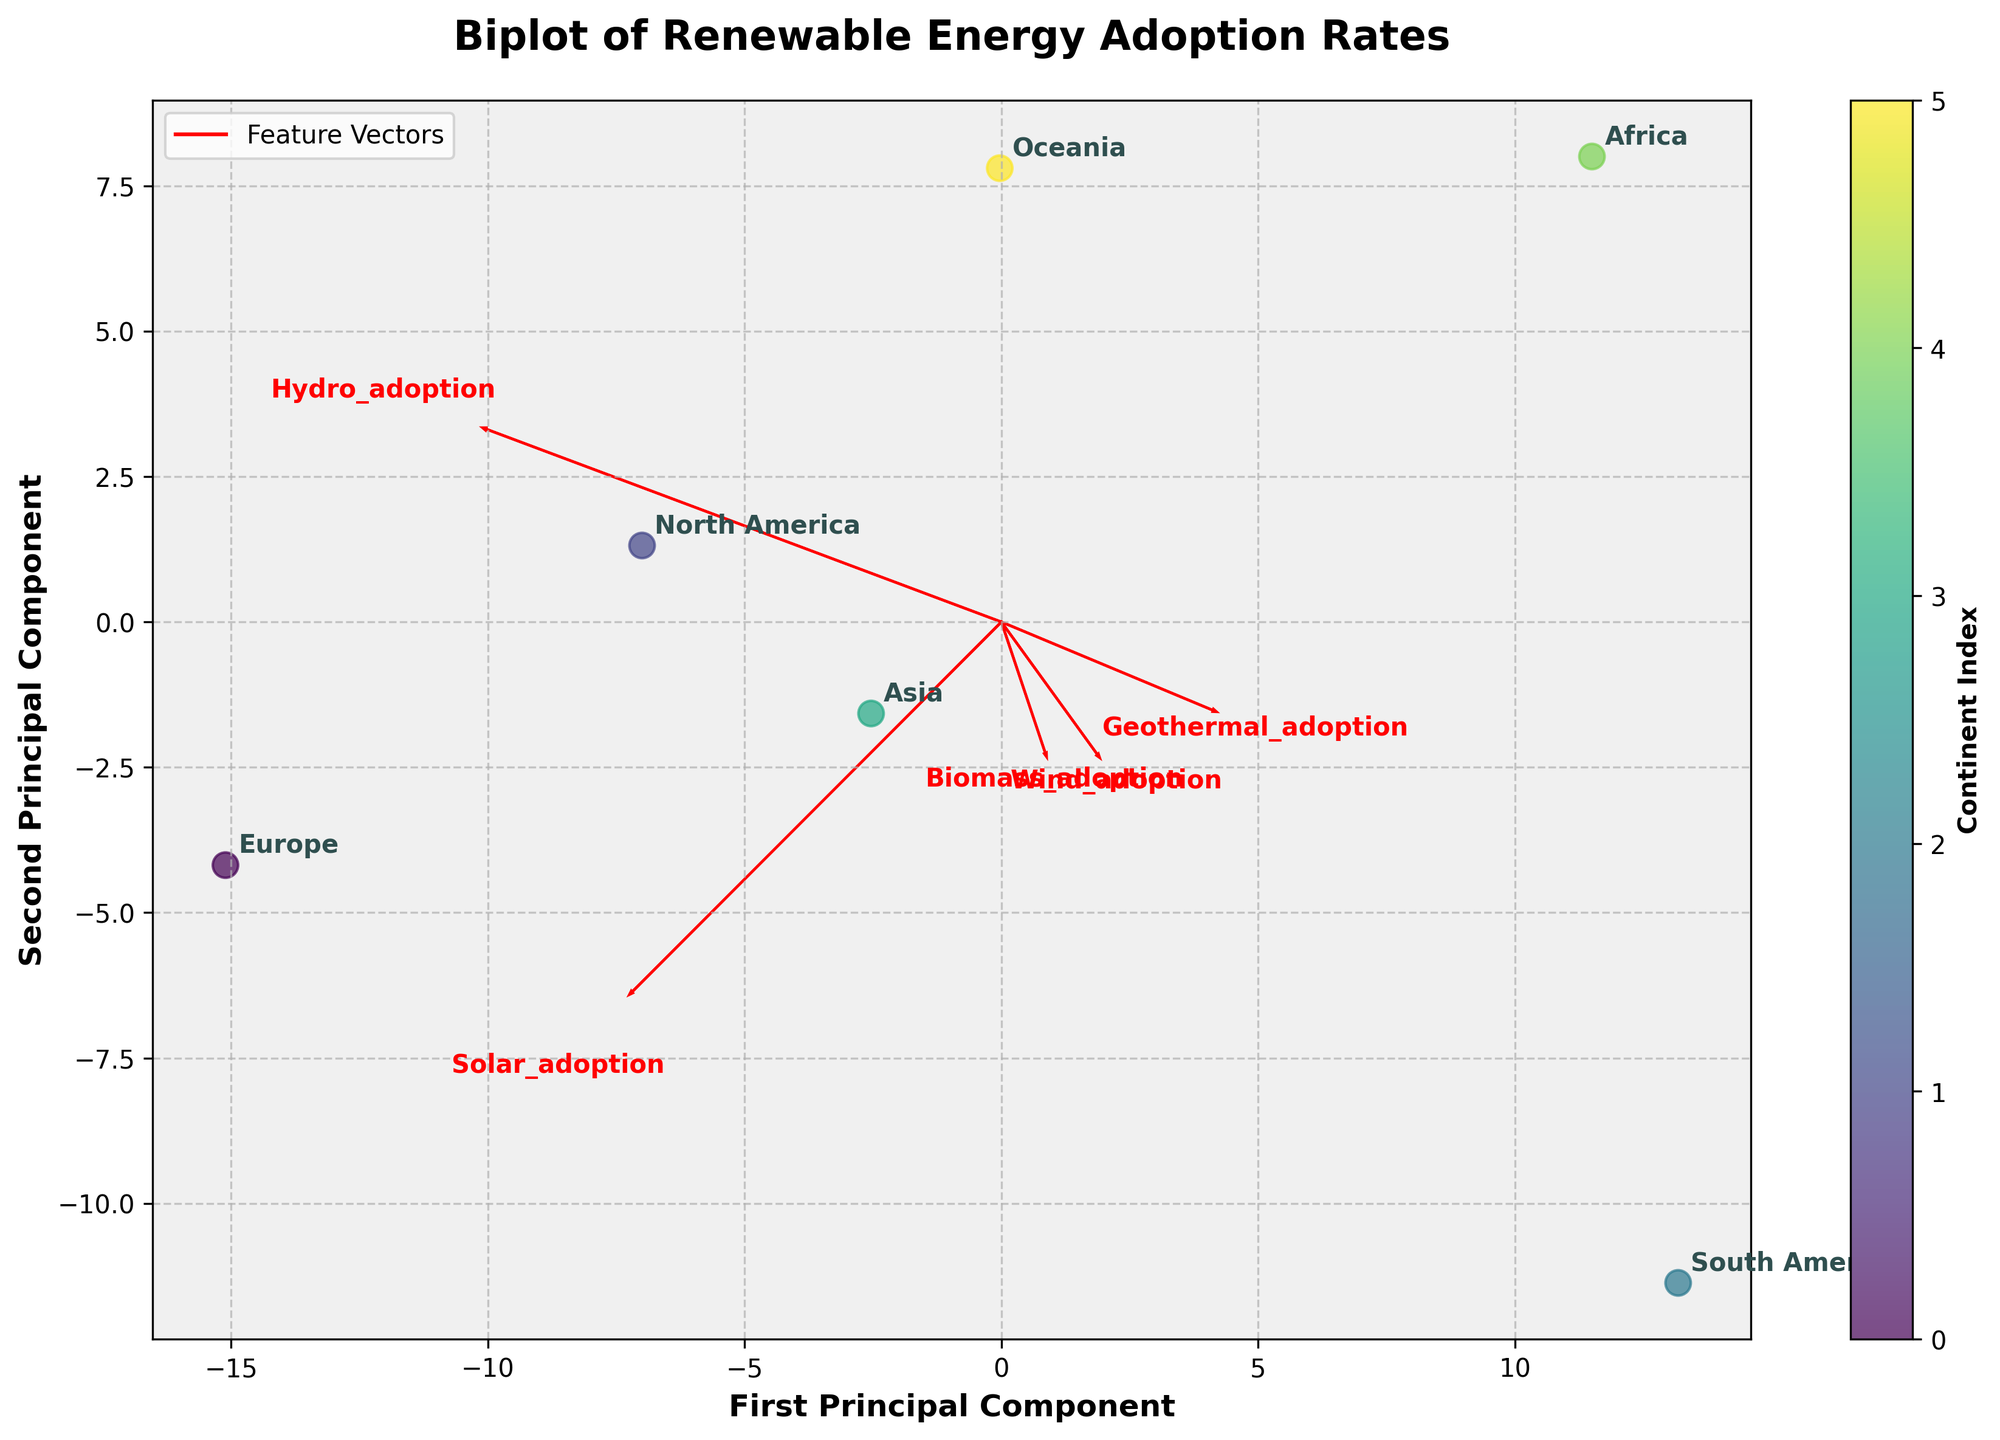What is the title of the biplot? The title is typically located at the top center of the plot and visually represents the main theme or topic being explored in the chart. Here, it is clearly seen as "Biplot of Renewable Energy Adoption Rates."
Answer: Biplot of Renewable Energy Adoption Rates Which feature vector has the longest arrow? Feature vectors in a biplot are represented by arrows emanating from the origin. The longest arrow corresponds to the feature with the most substantial variation. By examining the plot, "Solar_adoption" has the longest arrow.
Answer: Solar_adoption How many continents are labeled on the biplot? Each dot on the biplot represents a continent, labeled accordingly. By counting these labels, we can see there are six: Europe, North America, South America, Asia, Africa, and Oceania.
Answer: Six Which continent is closest to the origin? The origin is the point (0, 0) in the biplot. The continent labeled closest to the origin can be identified as having coordinates nearest to this point. In this case, Europe is closest to the origin.
Answer: Europe Between Europe and North America, which continent has a higher adoption rate for wind energy? By examining the position of Europe and North America relative to the "Wind_adoption" feature vector, we observe that Europe has a higher projection along the direction of this vector.
Answer: Europe Which renewable energy source shows a distinctive adoption pattern between Africa and Oceania? By comparing the feature vectors and the positions of Africa and Oceania, we can identify the most glaring differences in their positions relative to the feature vectors. "Biomass_adoption" shows a distinctive difference, as Africa is close to the origin and Oceania is further out along this vector.
Answer: Biomass_adoption What's the first and second principal component represented on the axis? The axes of the biplot typically represent the first two principal components of the PCA. This can be determined by their labels. Here, they are "First Principal Component" and "Second Principal Component."
Answer: First Principal Component and Second Principal Component Is the adoption rate of geothermal energy higher in Oceania or North America? By examining the positions of Oceania and North America relative to the "Geothermal_adoption" vector, Oceania has a higher projection along the direction of this vector.
Answer: Oceania Which continent has the lowest adoption rate for biomass energy? By observing the projection of continents along the "Biomass_adoption" vector, Africa has the position closest to the origin, indicating the lowest adoption rate.
Answer: Africa What's the average adoption rate for solar energy across all continents? The average adoption rate can be calculated by summing the given solar adoption rates for all continents and dividing by the number of continents. The rates given are 42, 37, 25, 40, 30, 35. Sum = 209; dividing by 6, the average is approximately 34.83.
Answer: 34.83 